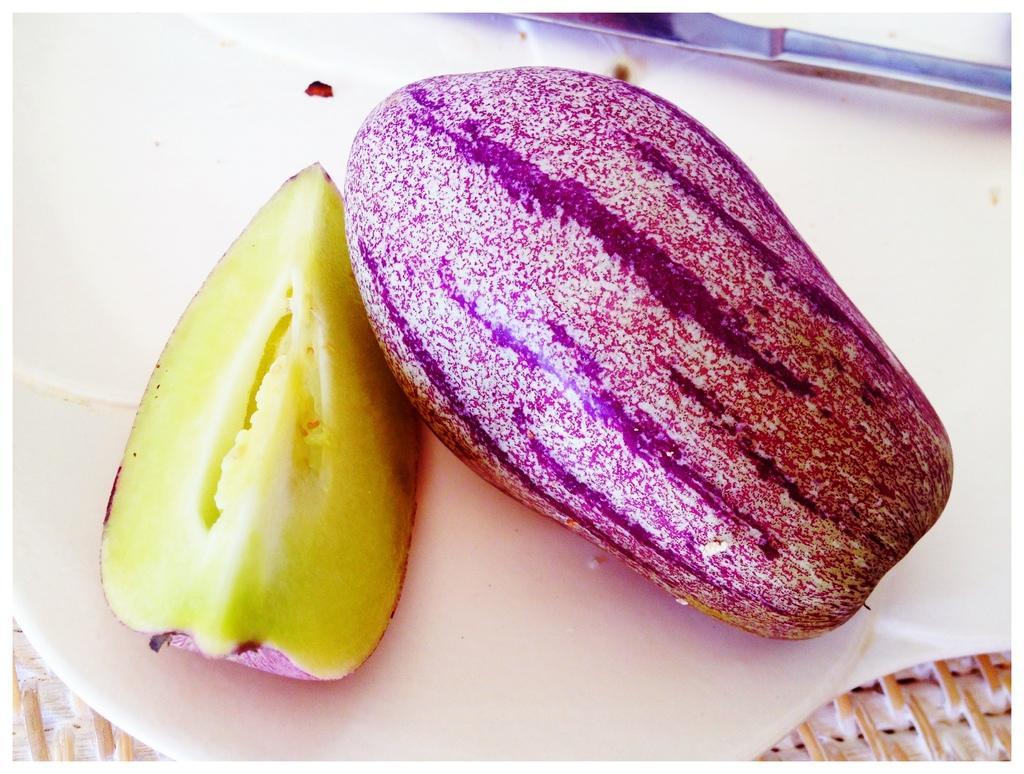Describe this image in one or two sentences. In this image we can see pepino fruits placed on the plate. 